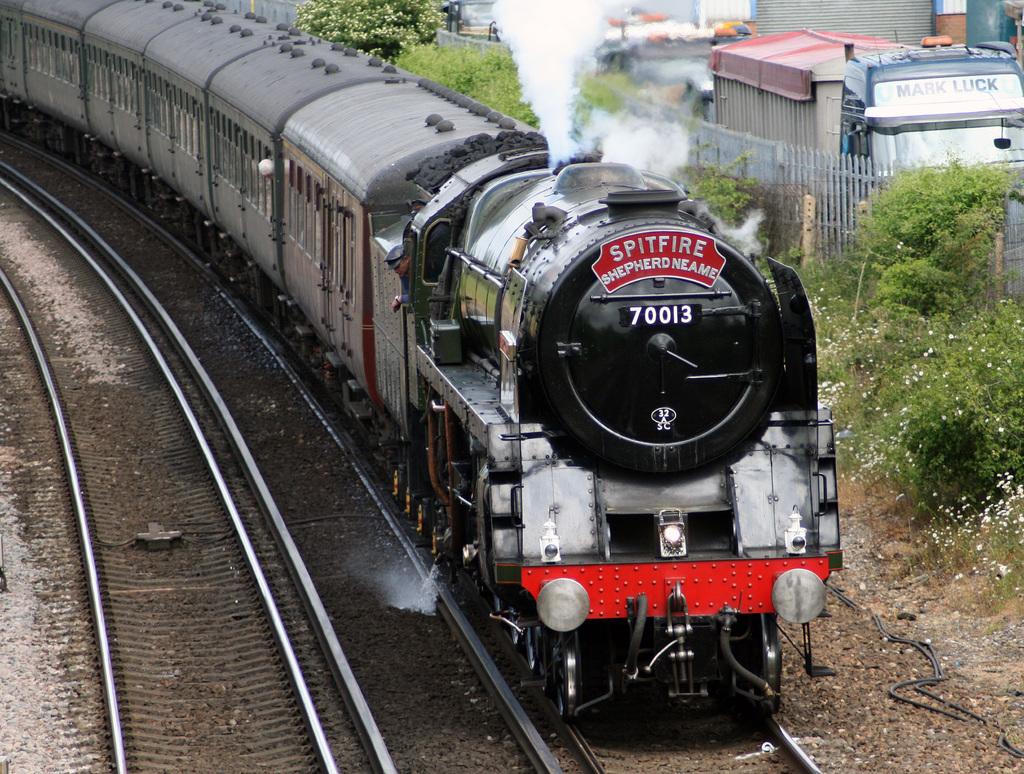What is the trains number?
Provide a short and direct response. 70013. What does it say above shepherd neame?
Ensure brevity in your answer.  Spitfire. 